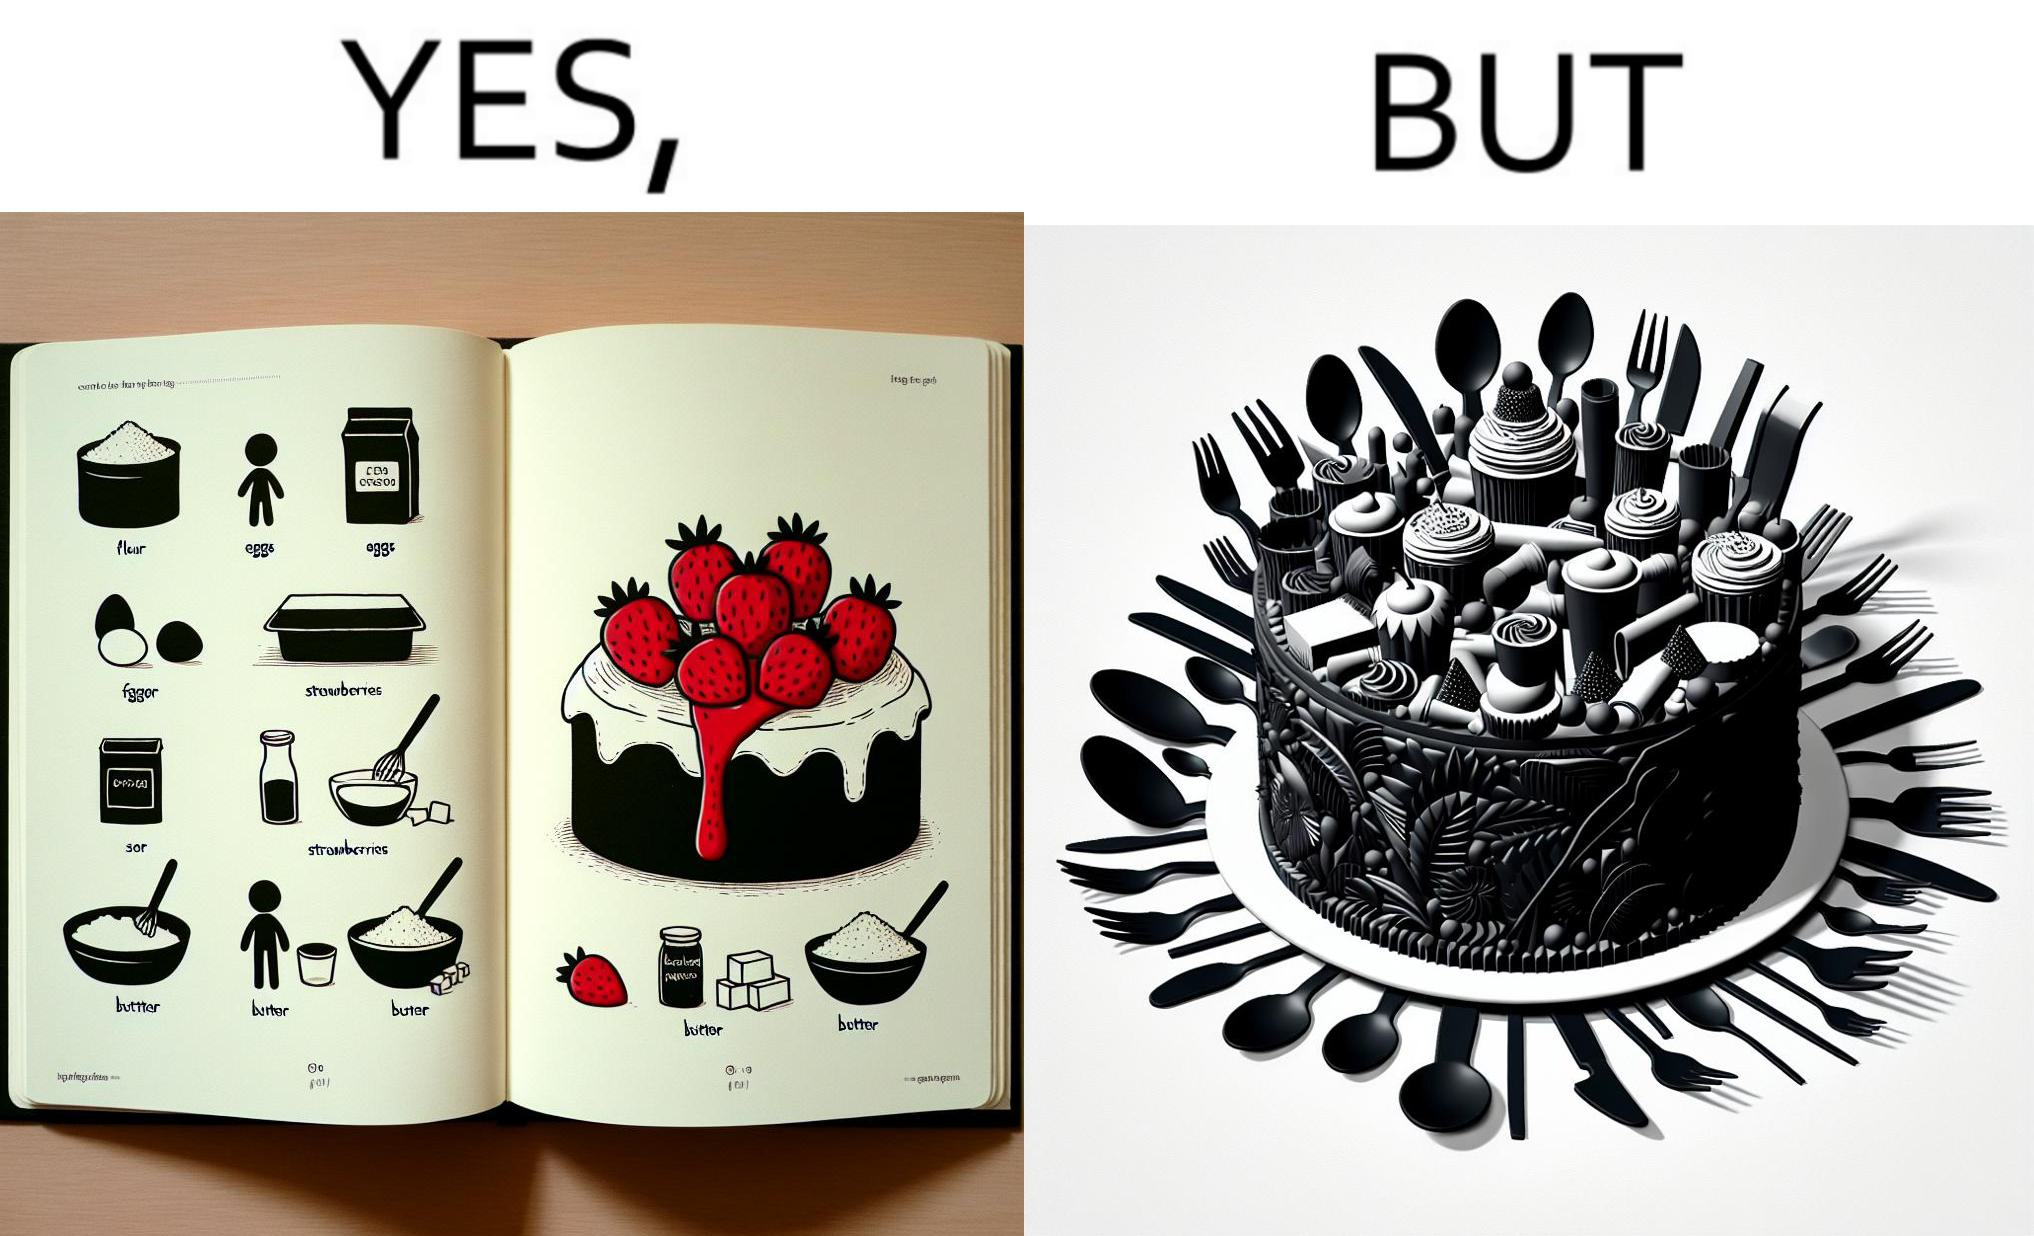Is there satirical content in this image? Yes, this image is satirical. 